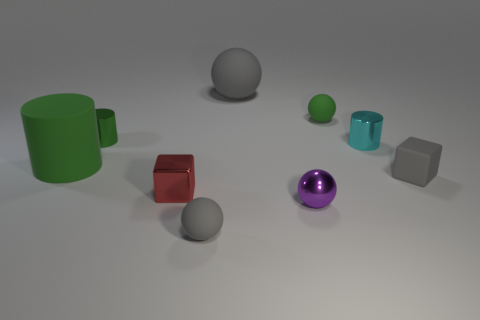Are there any other things that are the same size as the rubber block?
Offer a very short reply. Yes. Is the number of tiny spheres that are behind the small cyan cylinder the same as the number of tiny purple metallic things?
Provide a succinct answer. Yes. What number of tiny gray matte things are in front of the purple shiny object and right of the small gray ball?
Keep it short and to the point. 0. Does the green thing that is to the right of the purple ball have the same shape as the small cyan metal thing?
Offer a very short reply. No. What material is the gray thing that is the same size as the green matte cylinder?
Give a very brief answer. Rubber. Is the number of small shiny cubes behind the small matte block the same as the number of gray rubber blocks that are left of the tiny green rubber thing?
Keep it short and to the point. Yes. How many shiny cylinders are on the right side of the tiny shiny sphere that is on the right side of the gray sphere that is behind the cyan metal cylinder?
Your response must be concise. 1. Is the color of the small shiny cube the same as the tiny sphere that is behind the tiny cyan metal thing?
Your response must be concise. No. There is a cylinder that is the same material as the small green ball; what size is it?
Provide a short and direct response. Large. Is the number of tiny gray rubber things that are to the left of the metallic block greater than the number of big purple cylinders?
Provide a short and direct response. No. 